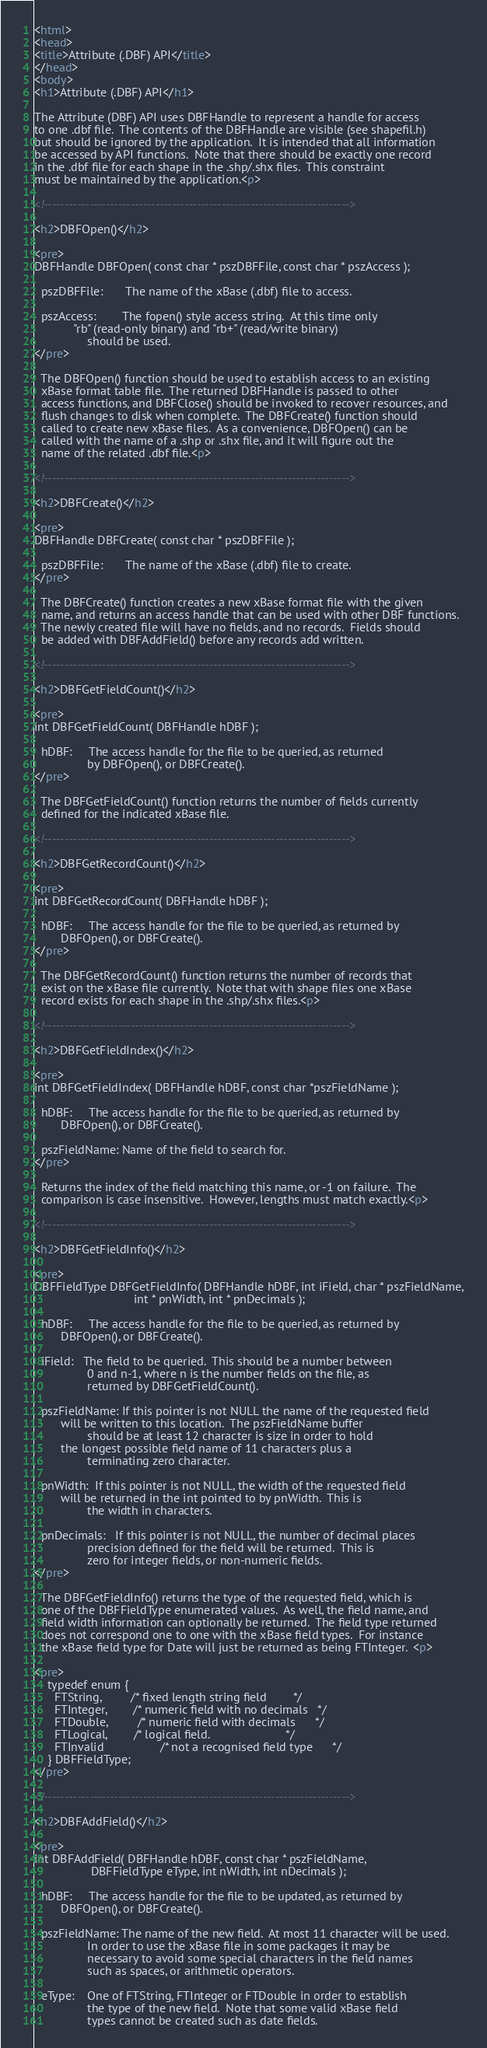<code> <loc_0><loc_0><loc_500><loc_500><_HTML_><html>
<head>
<title>Attribute (.DBF) API</title>
</head>
<body>
<h1>Attribute (.DBF) API</h1>

The Attribute (DBF) API uses DBFHandle to represent a handle for access
to one .dbf file.  The contents of the DBFHandle are visible (see shapefil.h)
but should be ignored by the application.  It is intended that all information
be accessed by API functions.  Note that there should be exactly one record
in the .dbf file for each shape in the .shp/.shx files.  This constraint
must be maintained by the application.<p>

<!-------------------------------------------------------------------------->

<h2>DBFOpen()</h2>

<pre>
DBFHandle DBFOpen( const char * pszDBFFile, const char * pszAccess );

  pszDBFFile:		The name of the xBase (.dbf) file to access.

  pszAccess:		The fopen() style access string.  At this time only
			"rb" (read-only binary) and "rb+" (read/write binary) 
		        should be used.
</pre>

  The DBFOpen() function should be used to establish access to an existing
  xBase format table file.  The returned DBFHandle is passed to other 
  access functions, and DBFClose() should be invoked to recover resources, and 
  flush changes to disk when complete.  The DBFCreate() function should
  called to create new xBase files.  As a convenience, DBFOpen() can be
  called with the name of a .shp or .shx file, and it will figure out the
  name of the related .dbf file.<p>

<!-------------------------------------------------------------------------->

<h2>DBFCreate()</h2>

<pre>
DBFHandle DBFCreate( const char * pszDBFFile );

  pszDBFFile:		The name of the xBase (.dbf) file to create.
</pre>
  
  The DBFCreate() function creates a new xBase format file with the given 
  name, and returns an access handle that can be used with other DBF functions.
  The newly created file will have no fields, and no records.  Fields should
  be added with DBFAddField() before any records add written.

<!-------------------------------------------------------------------------->

<h2>DBFGetFieldCount()</h2>

<pre>
int DBFGetFieldCount( DBFHandle hDBF );

  hDBF:		The access handle for the file to be queried, as returned
                by DBFOpen(), or DBFCreate().
</pre>

  The DBFGetFieldCount() function returns the number of fields currently
  defined for the indicated xBase file.

<!-------------------------------------------------------------------------->

<h2>DBFGetRecordCount()</h2>

<pre>
int DBFGetRecordCount( DBFHandle hDBF );

  hDBF:		The access handle for the file to be queried, as returned by
		DBFOpen(), or DBFCreate().
</pre>

  The DBFGetRecordCount() function returns the number of records that
  exist on the xBase file currently.  Note that with shape files one xBase
  record exists for each shape in the .shp/.shx files.<p>

<!-------------------------------------------------------------------------->

<h2>DBFGetFieldIndex()</h2>

<pre>
int DBFGetFieldIndex( DBFHandle hDBF, const char *pszFieldName );

  hDBF:		The access handle for the file to be queried, as returned by
		DBFOpen(), or DBFCreate().

  pszFieldName: Name of the field to search for.
</pre>

  Returns the index of the field matching this name, or -1 on failure.  The
  comparison is case insensitive.  However, lengths must match exactly.<p>

<!-------------------------------------------------------------------------->

<h2>DBFGetFieldInfo()</h2>

<pre>
DBFFieldType DBFGetFieldInfo( DBFHandle hDBF, int iField, char * pszFieldName,
                              int * pnWidth, int * pnDecimals );

  hDBF:		The access handle for the file to be queried, as returned by
		DBFOpen(), or DBFCreate().

  iField:	The field to be queried.  This should be a number between 
                0 and n-1, where n is the number fields on the file, as
                returned by DBFGetFieldCount().

  pszFieldName:	If this pointer is not NULL the name of the requested field
		will be written to this location.  The pszFieldName buffer 
                should be at least 12 character is size in order to hold
		the longest possible field name of 11 characters plus a 
                terminating zero character.

  pnWidth:	If this pointer is not NULL, the width of the requested field
		will be returned in the int pointed to by pnWidth.  This is
                the width in characters.  

  pnDecimals:	If this pointer is not NULL, the number of decimal places
                precision defined for the field will be returned.  This is
                zero for integer fields, or non-numeric fields.
</pre>

  The DBFGetFieldInfo() returns the type of the requested field, which is
  one of the DBFFieldType enumerated values.  As well, the field name, and
  field width information can optionally be returned.  The field type returned
  does not correspond one to one with the xBase field types.  For instance
  the xBase field type for Date will just be returned as being FTInteger.  <p>

<pre>
    typedef enum {
      FTString,			/* fixed length string field 		*/
      FTInteger,		/* numeric field with no decimals 	*/
      FTDouble,			/* numeric field with decimals 		*/
      FTLogical,		/* logical field.                       */
      FTInvalid                 /* not a recognised field type 		*/
    } DBFFieldType;
</pre>

<!-------------------------------------------------------------------------->

<h2>DBFAddField()</h2>

<pre>
int DBFAddField( DBFHandle hDBF, const char * pszFieldName, 
                 DBFFieldType eType, int nWidth, int nDecimals );

  hDBF:		The access handle for the file to be updated, as returned by
		DBFOpen(), or DBFCreate().

  pszFieldName:	The name of the new field.  At most 11 character will be used.
                In order to use the xBase file in some packages it may be
                necessary to avoid some special characters in the field names
                such as spaces, or arithmetic operators.

  eType:	One of FTString, FTInteger or FTDouble in order to establish
                the type of the new field.  Note that some valid xBase field
                types cannot be created such as date fields.
</code> 